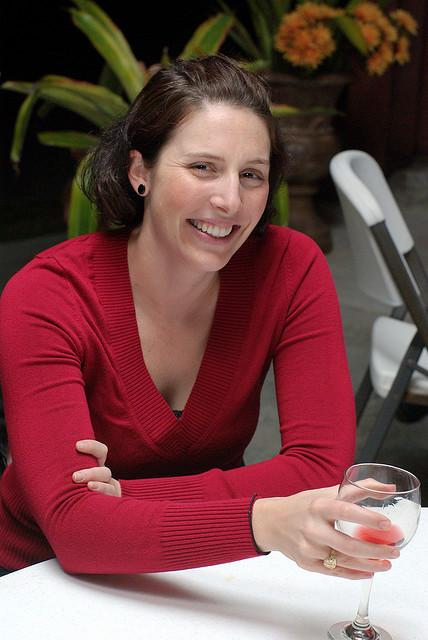What drink goes in this type of glass?

Choices:
A) coffee
B) tea
C) beer
D) wine wine 